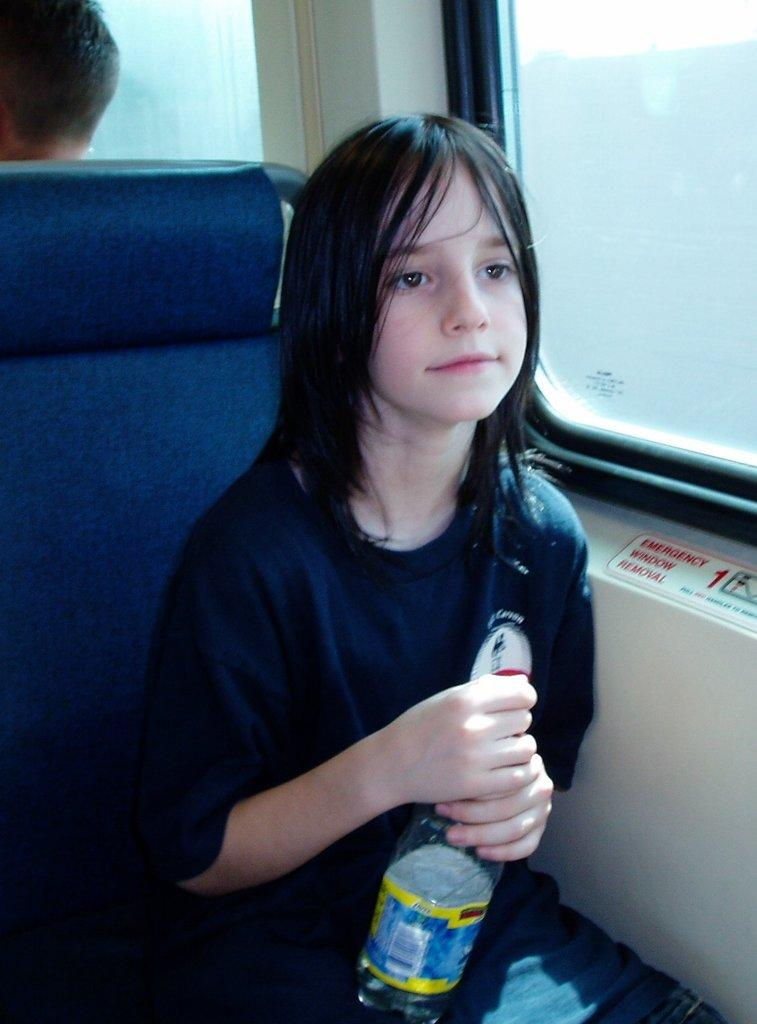What is the person in the image doing? The person is sitting on a seat. What is the person holding in the image? The person is holding a bottle. What can be seen in the background of the image? There is a window visible in the background. Can you see any letters on the rifle in the image? There is no rifle present in the image, so it is not possible to see any letters on it. 